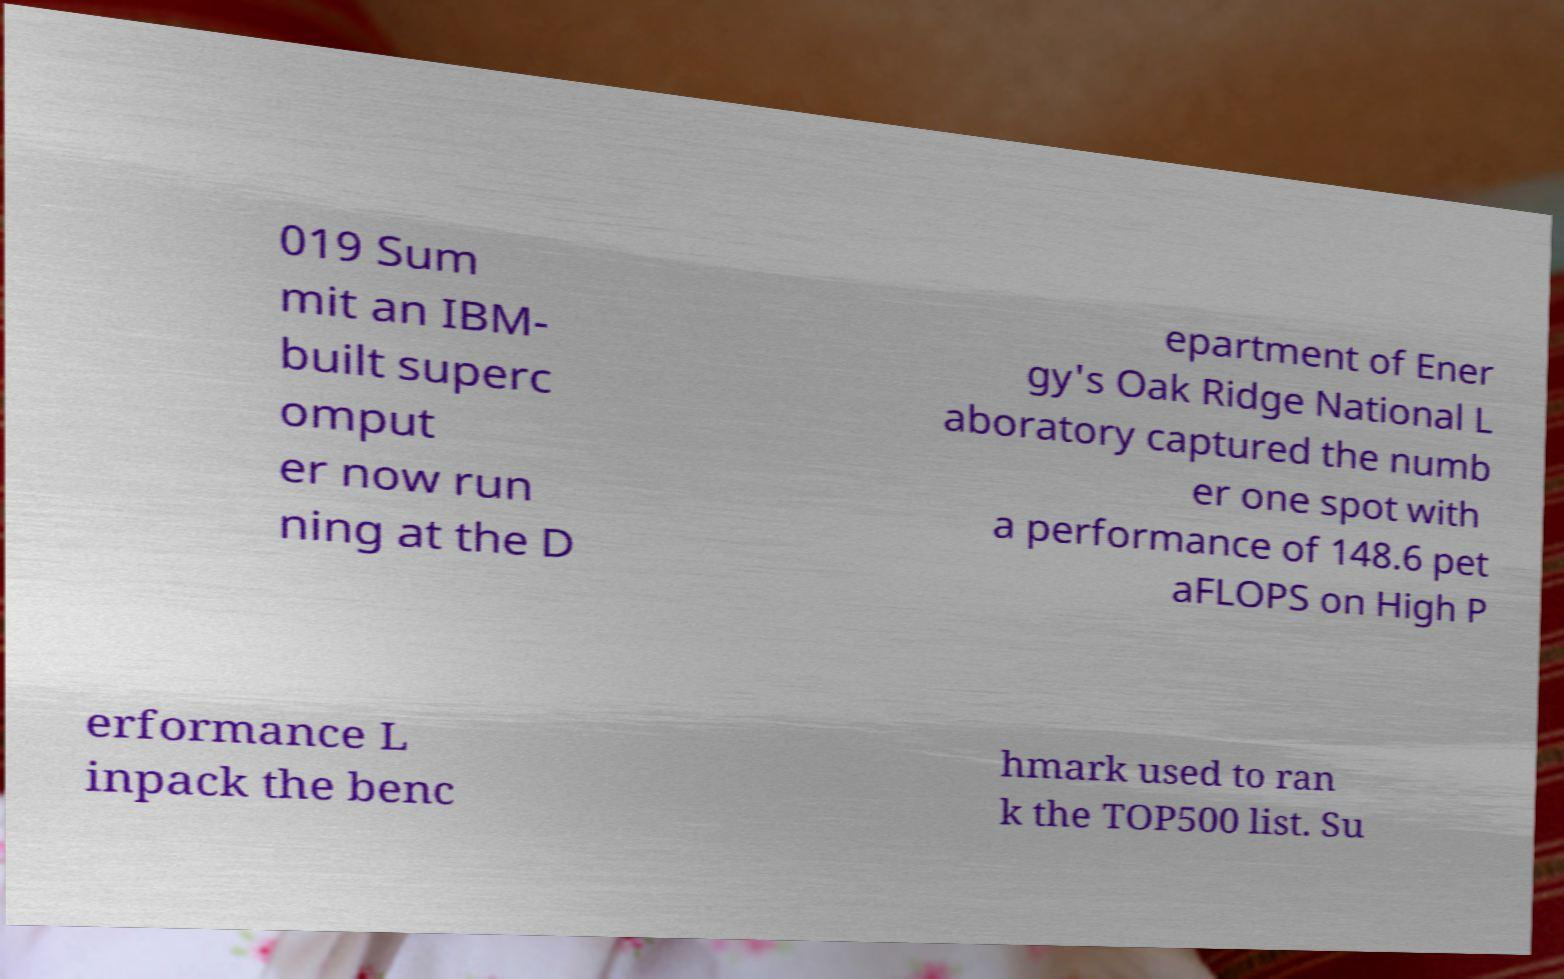What messages or text are displayed in this image? I need them in a readable, typed format. 019 Sum mit an IBM- built superc omput er now run ning at the D epartment of Ener gy's Oak Ridge National L aboratory captured the numb er one spot with a performance of 148.6 pet aFLOPS on High P erformance L inpack the benc hmark used to ran k the TOP500 list. Su 